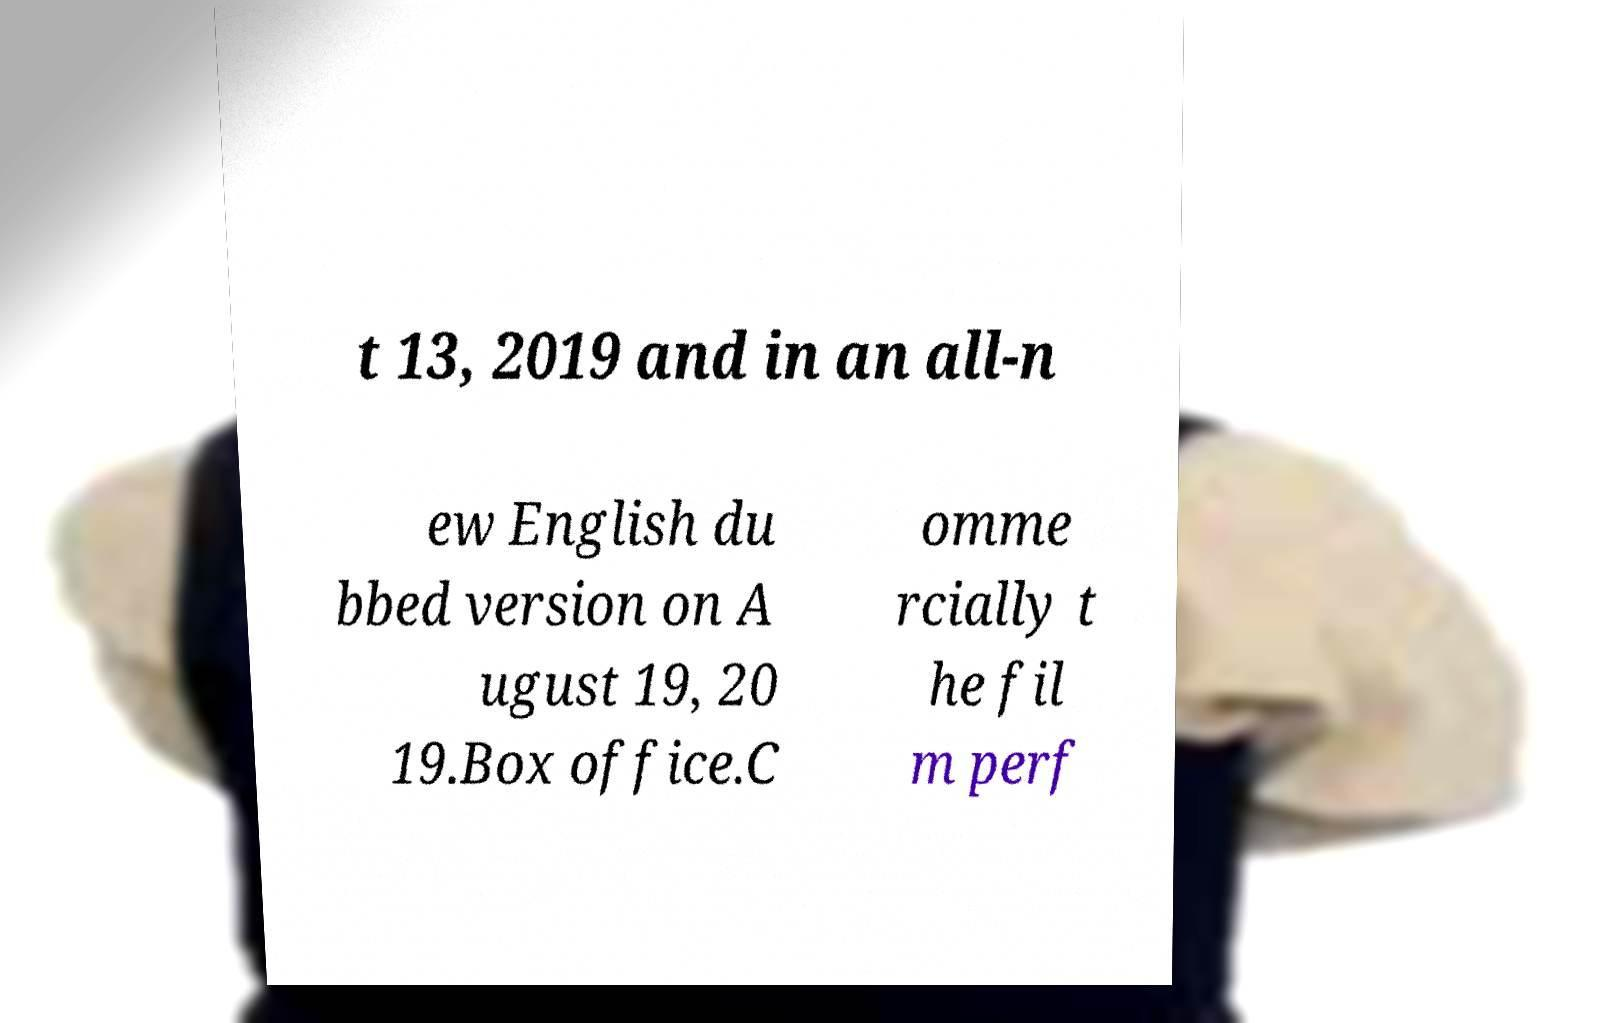Can you accurately transcribe the text from the provided image for me? t 13, 2019 and in an all-n ew English du bbed version on A ugust 19, 20 19.Box office.C omme rcially t he fil m perf 